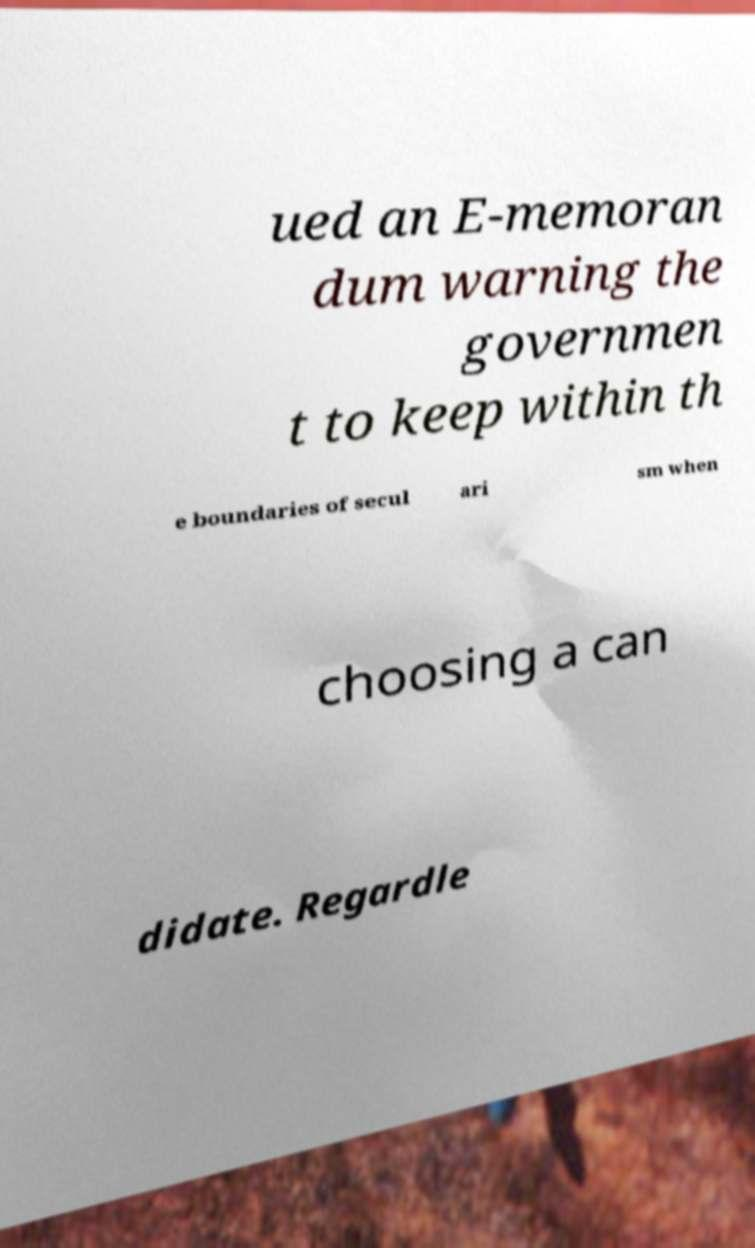Please read and relay the text visible in this image. What does it say? ued an E-memoran dum warning the governmen t to keep within th e boundaries of secul ari sm when choosing a can didate. Regardle 